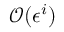<formula> <loc_0><loc_0><loc_500><loc_500>\mathcal { O } ( \epsilon ^ { i } )</formula> 